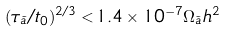Convert formula to latex. <formula><loc_0><loc_0><loc_500><loc_500>( \tau _ { \tilde { a } } / t _ { 0 } ) ^ { 2 / 3 } < 1 . 4 \times 1 0 ^ { - 7 } \Omega _ { \tilde { a } } h ^ { 2 }</formula> 